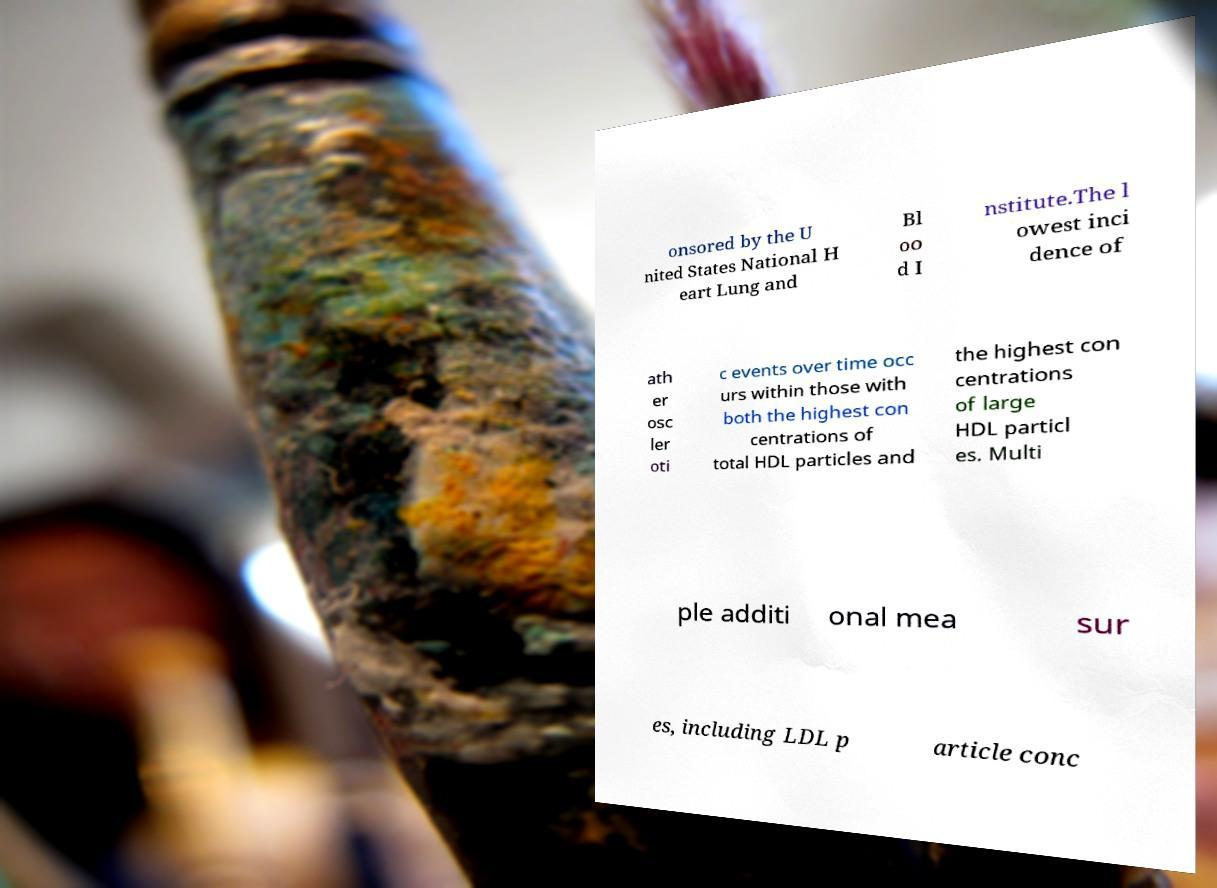Can you read and provide the text displayed in the image?This photo seems to have some interesting text. Can you extract and type it out for me? onsored by the U nited States National H eart Lung and Bl oo d I nstitute.The l owest inci dence of ath er osc ler oti c events over time occ urs within those with both the highest con centrations of total HDL particles and the highest con centrations of large HDL particl es. Multi ple additi onal mea sur es, including LDL p article conc 